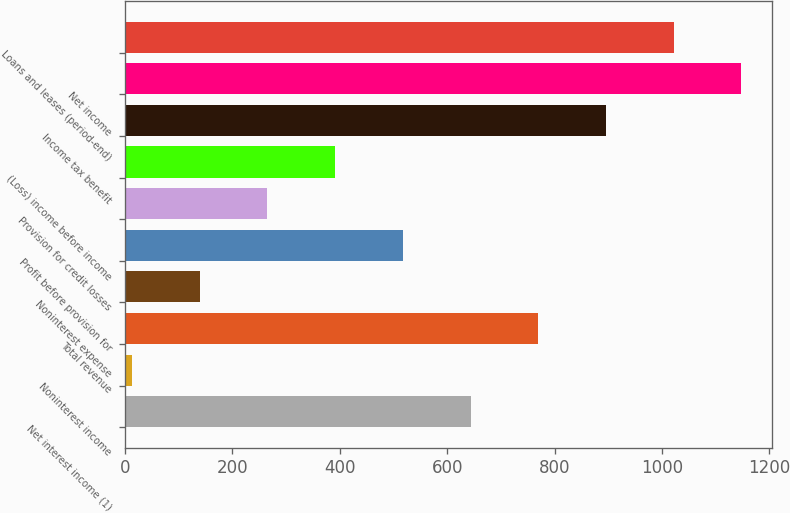Convert chart. <chart><loc_0><loc_0><loc_500><loc_500><bar_chart><fcel>Net interest income (1)<fcel>Noninterest income<fcel>Total revenue<fcel>Noninterest expense<fcel>Profit before provision for<fcel>Provision for credit losses<fcel>(Loss) income before income<fcel>Income tax benefit<fcel>Net income<fcel>Loans and leases (period-end)<nl><fcel>643.5<fcel>13<fcel>769.6<fcel>139.1<fcel>517.4<fcel>265.2<fcel>391.3<fcel>895.7<fcel>1147.9<fcel>1021.8<nl></chart> 